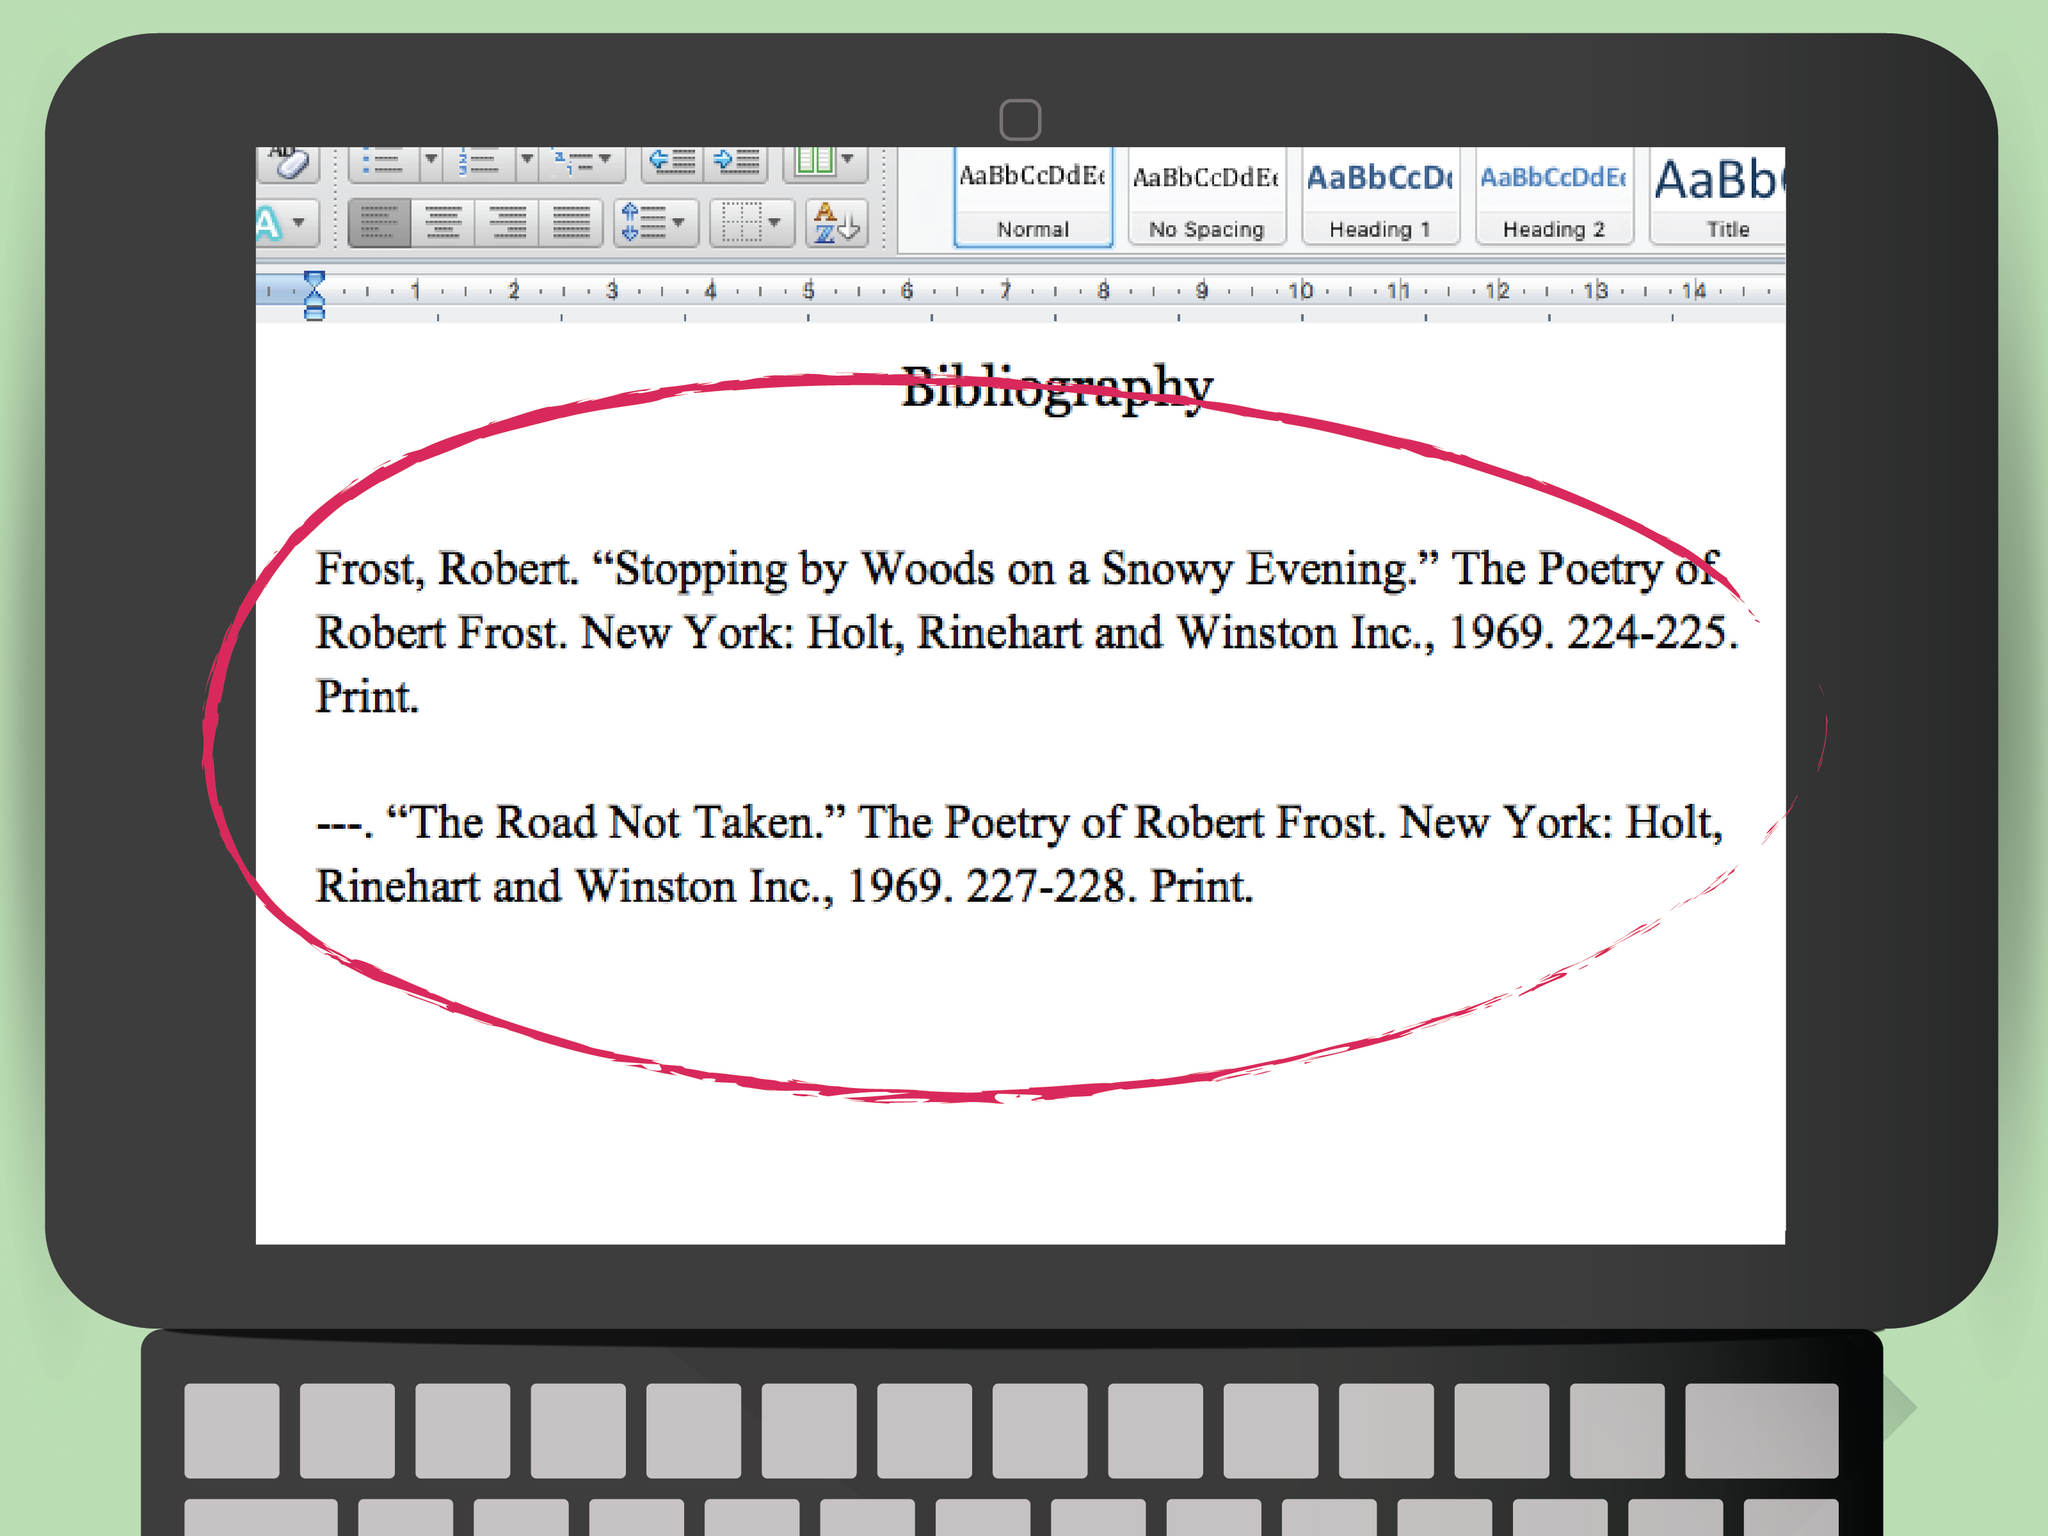Can you analyze why these specific entries from Robert Frost's poetry are significant and how they might be used in a project? These particular entries, 'Stopping by Woods on a Snowy Evening' and 'The Road Not Taken,' are among Robert Frost's most celebrated works. Their themes of contemplation, nature, and decision-making are rich in meaning and widely analyzed. The user could be using these poems to explore themes of life's choices and natural beauty in their project, perhaps drawing parallels to contemporary issues or extracting literary techniques for deeper analysis. How might one interpret the symbolism in 'The Road Not Taken' for a literature paper? In 'The Road Not Taken,' the diverging roads symbolize the choices we encounter in life, each path representing a different direction one can take. Interpreting this for a literature paper might involve examining how Frost uses this metaphor to address the nature of decision-making and its inherent uncertainties. Discussing how the traveler's choice, though seemingly unique, reflects a universal human experience of contemplation and regret can add depth to the analysis. What could be a creative way to draw connections between these poems and modern life? One creative approach could be to juxtapose Frost's contemplative moments in nature with our current digital age's fast-paced lifestyle. Discuss how the serene, reflective spaces Frost describes are becoming a rarity, and how his emphasis on introspection is more relevant than ever in today's world of constant connectivity. You might also draw parallels between the 'roads' in Frost's poems and the countless choices we make online, from social media interactions to career decisions shaped by technological advancements. If Robert Frost were alive today, how might he incorporate modern themes into his poetry? If Robert Frost were alive today, he might incorporate themes like the fragility of our natural environment amidst climate change, the paradox of connectivity and isolation in the digital age, and the rapid pace of societal change. Imagining urban landscapes as new-age woods, filled with metaphorical 'snowy evenings,' and 'roads not taken,' Frost could explore current existential dilemmas through the lens of modernity, blending his timeless introspection with the contemporary challenges we face. 